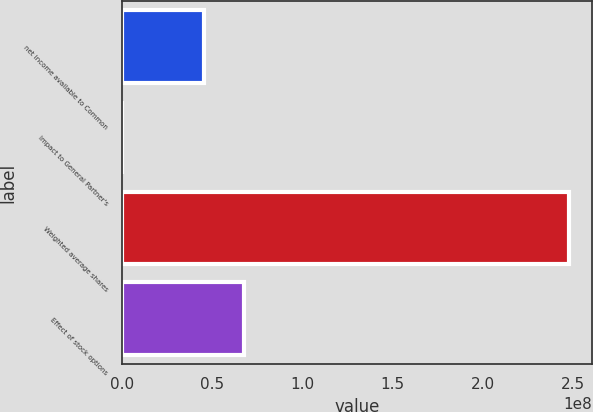<chart> <loc_0><loc_0><loc_500><loc_500><bar_chart><fcel>net income available to Common<fcel>Impact to General Partner's<fcel>Weighted average shares<fcel>Effect of stock options<nl><fcel>4.51769e+07<fcel>209<fcel>2.47921e+08<fcel>6.77652e+07<nl></chart> 